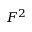<formula> <loc_0><loc_0><loc_500><loc_500>F ^ { 2 }</formula> 